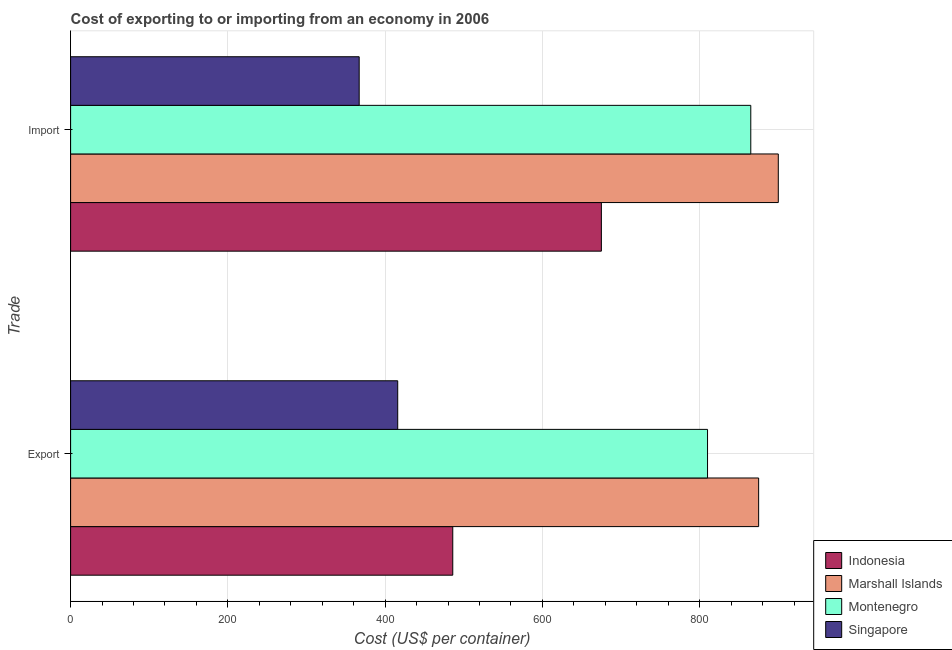Are the number of bars on each tick of the Y-axis equal?
Make the answer very short. Yes. How many bars are there on the 2nd tick from the top?
Make the answer very short. 4. How many bars are there on the 2nd tick from the bottom?
Your answer should be very brief. 4. What is the label of the 1st group of bars from the top?
Offer a terse response. Import. What is the export cost in Indonesia?
Offer a terse response. 486. Across all countries, what is the maximum export cost?
Provide a short and direct response. 875. Across all countries, what is the minimum import cost?
Offer a terse response. 367. In which country was the import cost maximum?
Provide a succinct answer. Marshall Islands. In which country was the import cost minimum?
Your answer should be compact. Singapore. What is the total import cost in the graph?
Your response must be concise. 2807. What is the difference between the export cost in Marshall Islands and that in Montenegro?
Provide a short and direct response. 65. What is the difference between the import cost in Montenegro and the export cost in Singapore?
Provide a short and direct response. 449. What is the average import cost per country?
Provide a short and direct response. 701.75. What is the difference between the export cost and import cost in Montenegro?
Your answer should be very brief. -55. What is the ratio of the import cost in Marshall Islands to that in Indonesia?
Offer a terse response. 1.33. Is the export cost in Singapore less than that in Montenegro?
Your response must be concise. Yes. What does the 3rd bar from the top in Export represents?
Your answer should be compact. Marshall Islands. What does the 3rd bar from the bottom in Import represents?
Keep it short and to the point. Montenegro. How many countries are there in the graph?
Make the answer very short. 4. What is the difference between two consecutive major ticks on the X-axis?
Ensure brevity in your answer.  200. Are the values on the major ticks of X-axis written in scientific E-notation?
Make the answer very short. No. Does the graph contain any zero values?
Offer a terse response. No. Does the graph contain grids?
Offer a very short reply. Yes. Where does the legend appear in the graph?
Your answer should be compact. Bottom right. What is the title of the graph?
Keep it short and to the point. Cost of exporting to or importing from an economy in 2006. What is the label or title of the X-axis?
Ensure brevity in your answer.  Cost (US$ per container). What is the label or title of the Y-axis?
Offer a terse response. Trade. What is the Cost (US$ per container) in Indonesia in Export?
Ensure brevity in your answer.  486. What is the Cost (US$ per container) in Marshall Islands in Export?
Your answer should be very brief. 875. What is the Cost (US$ per container) in Montenegro in Export?
Ensure brevity in your answer.  810. What is the Cost (US$ per container) in Singapore in Export?
Your answer should be compact. 416. What is the Cost (US$ per container) in Indonesia in Import?
Offer a terse response. 675. What is the Cost (US$ per container) of Marshall Islands in Import?
Provide a succinct answer. 900. What is the Cost (US$ per container) of Montenegro in Import?
Make the answer very short. 865. What is the Cost (US$ per container) in Singapore in Import?
Make the answer very short. 367. Across all Trade, what is the maximum Cost (US$ per container) in Indonesia?
Your answer should be compact. 675. Across all Trade, what is the maximum Cost (US$ per container) in Marshall Islands?
Give a very brief answer. 900. Across all Trade, what is the maximum Cost (US$ per container) in Montenegro?
Make the answer very short. 865. Across all Trade, what is the maximum Cost (US$ per container) of Singapore?
Your answer should be compact. 416. Across all Trade, what is the minimum Cost (US$ per container) of Indonesia?
Offer a terse response. 486. Across all Trade, what is the minimum Cost (US$ per container) in Marshall Islands?
Provide a succinct answer. 875. Across all Trade, what is the minimum Cost (US$ per container) of Montenegro?
Offer a very short reply. 810. Across all Trade, what is the minimum Cost (US$ per container) in Singapore?
Offer a very short reply. 367. What is the total Cost (US$ per container) in Indonesia in the graph?
Make the answer very short. 1161. What is the total Cost (US$ per container) in Marshall Islands in the graph?
Provide a succinct answer. 1775. What is the total Cost (US$ per container) in Montenegro in the graph?
Your answer should be very brief. 1675. What is the total Cost (US$ per container) of Singapore in the graph?
Offer a very short reply. 783. What is the difference between the Cost (US$ per container) of Indonesia in Export and that in Import?
Your response must be concise. -189. What is the difference between the Cost (US$ per container) of Marshall Islands in Export and that in Import?
Give a very brief answer. -25. What is the difference between the Cost (US$ per container) of Montenegro in Export and that in Import?
Provide a short and direct response. -55. What is the difference between the Cost (US$ per container) of Indonesia in Export and the Cost (US$ per container) of Marshall Islands in Import?
Your response must be concise. -414. What is the difference between the Cost (US$ per container) in Indonesia in Export and the Cost (US$ per container) in Montenegro in Import?
Your answer should be compact. -379. What is the difference between the Cost (US$ per container) of Indonesia in Export and the Cost (US$ per container) of Singapore in Import?
Offer a terse response. 119. What is the difference between the Cost (US$ per container) of Marshall Islands in Export and the Cost (US$ per container) of Singapore in Import?
Your answer should be very brief. 508. What is the difference between the Cost (US$ per container) in Montenegro in Export and the Cost (US$ per container) in Singapore in Import?
Ensure brevity in your answer.  443. What is the average Cost (US$ per container) of Indonesia per Trade?
Provide a short and direct response. 580.5. What is the average Cost (US$ per container) in Marshall Islands per Trade?
Offer a very short reply. 887.5. What is the average Cost (US$ per container) in Montenegro per Trade?
Provide a succinct answer. 837.5. What is the average Cost (US$ per container) in Singapore per Trade?
Your answer should be very brief. 391.5. What is the difference between the Cost (US$ per container) in Indonesia and Cost (US$ per container) in Marshall Islands in Export?
Ensure brevity in your answer.  -389. What is the difference between the Cost (US$ per container) in Indonesia and Cost (US$ per container) in Montenegro in Export?
Give a very brief answer. -324. What is the difference between the Cost (US$ per container) in Indonesia and Cost (US$ per container) in Singapore in Export?
Your answer should be compact. 70. What is the difference between the Cost (US$ per container) in Marshall Islands and Cost (US$ per container) in Montenegro in Export?
Keep it short and to the point. 65. What is the difference between the Cost (US$ per container) of Marshall Islands and Cost (US$ per container) of Singapore in Export?
Offer a terse response. 459. What is the difference between the Cost (US$ per container) in Montenegro and Cost (US$ per container) in Singapore in Export?
Provide a short and direct response. 394. What is the difference between the Cost (US$ per container) of Indonesia and Cost (US$ per container) of Marshall Islands in Import?
Offer a very short reply. -225. What is the difference between the Cost (US$ per container) of Indonesia and Cost (US$ per container) of Montenegro in Import?
Your response must be concise. -190. What is the difference between the Cost (US$ per container) in Indonesia and Cost (US$ per container) in Singapore in Import?
Provide a short and direct response. 308. What is the difference between the Cost (US$ per container) in Marshall Islands and Cost (US$ per container) in Singapore in Import?
Ensure brevity in your answer.  533. What is the difference between the Cost (US$ per container) of Montenegro and Cost (US$ per container) of Singapore in Import?
Offer a terse response. 498. What is the ratio of the Cost (US$ per container) in Indonesia in Export to that in Import?
Provide a succinct answer. 0.72. What is the ratio of the Cost (US$ per container) in Marshall Islands in Export to that in Import?
Provide a succinct answer. 0.97. What is the ratio of the Cost (US$ per container) in Montenegro in Export to that in Import?
Keep it short and to the point. 0.94. What is the ratio of the Cost (US$ per container) in Singapore in Export to that in Import?
Offer a terse response. 1.13. What is the difference between the highest and the second highest Cost (US$ per container) of Indonesia?
Make the answer very short. 189. What is the difference between the highest and the second highest Cost (US$ per container) of Marshall Islands?
Keep it short and to the point. 25. What is the difference between the highest and the second highest Cost (US$ per container) in Montenegro?
Your answer should be very brief. 55. What is the difference between the highest and the second highest Cost (US$ per container) of Singapore?
Keep it short and to the point. 49. What is the difference between the highest and the lowest Cost (US$ per container) in Indonesia?
Your answer should be compact. 189. What is the difference between the highest and the lowest Cost (US$ per container) in Singapore?
Offer a terse response. 49. 